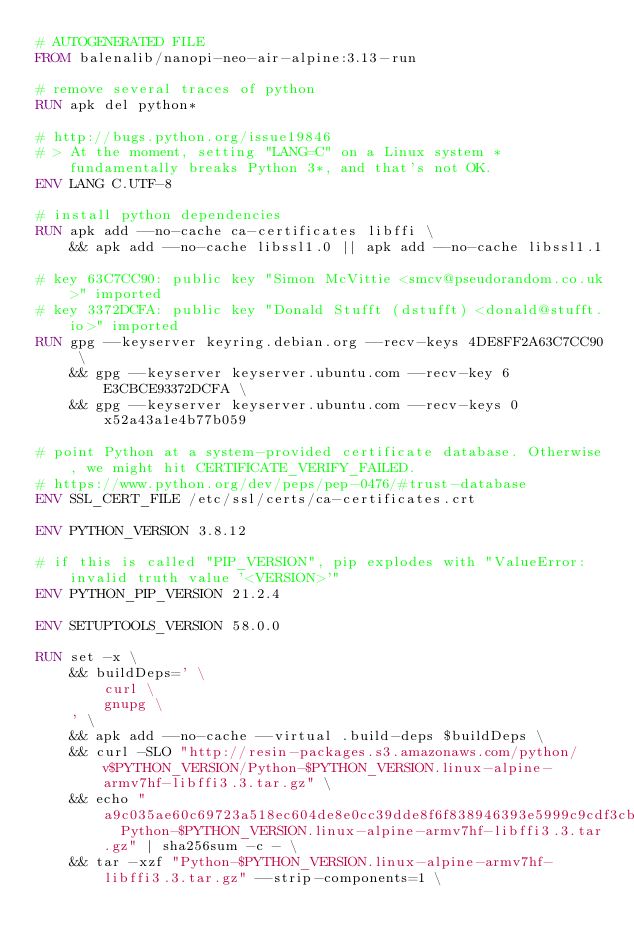<code> <loc_0><loc_0><loc_500><loc_500><_Dockerfile_># AUTOGENERATED FILE
FROM balenalib/nanopi-neo-air-alpine:3.13-run

# remove several traces of python
RUN apk del python*

# http://bugs.python.org/issue19846
# > At the moment, setting "LANG=C" on a Linux system *fundamentally breaks Python 3*, and that's not OK.
ENV LANG C.UTF-8

# install python dependencies
RUN apk add --no-cache ca-certificates libffi \
	&& apk add --no-cache libssl1.0 || apk add --no-cache libssl1.1

# key 63C7CC90: public key "Simon McVittie <smcv@pseudorandom.co.uk>" imported
# key 3372DCFA: public key "Donald Stufft (dstufft) <donald@stufft.io>" imported
RUN gpg --keyserver keyring.debian.org --recv-keys 4DE8FF2A63C7CC90 \
	&& gpg --keyserver keyserver.ubuntu.com --recv-key 6E3CBCE93372DCFA \
	&& gpg --keyserver keyserver.ubuntu.com --recv-keys 0x52a43a1e4b77b059

# point Python at a system-provided certificate database. Otherwise, we might hit CERTIFICATE_VERIFY_FAILED.
# https://www.python.org/dev/peps/pep-0476/#trust-database
ENV SSL_CERT_FILE /etc/ssl/certs/ca-certificates.crt

ENV PYTHON_VERSION 3.8.12

# if this is called "PIP_VERSION", pip explodes with "ValueError: invalid truth value '<VERSION>'"
ENV PYTHON_PIP_VERSION 21.2.4

ENV SETUPTOOLS_VERSION 58.0.0

RUN set -x \
	&& buildDeps=' \
		curl \
		gnupg \
	' \
	&& apk add --no-cache --virtual .build-deps $buildDeps \
	&& curl -SLO "http://resin-packages.s3.amazonaws.com/python/v$PYTHON_VERSION/Python-$PYTHON_VERSION.linux-alpine-armv7hf-libffi3.3.tar.gz" \
	&& echo "a9c035ae60c69723a518ec604de8e0cc39dde8f6f838946393e5999c9cdf3cba  Python-$PYTHON_VERSION.linux-alpine-armv7hf-libffi3.3.tar.gz" | sha256sum -c - \
	&& tar -xzf "Python-$PYTHON_VERSION.linux-alpine-armv7hf-libffi3.3.tar.gz" --strip-components=1 \</code> 